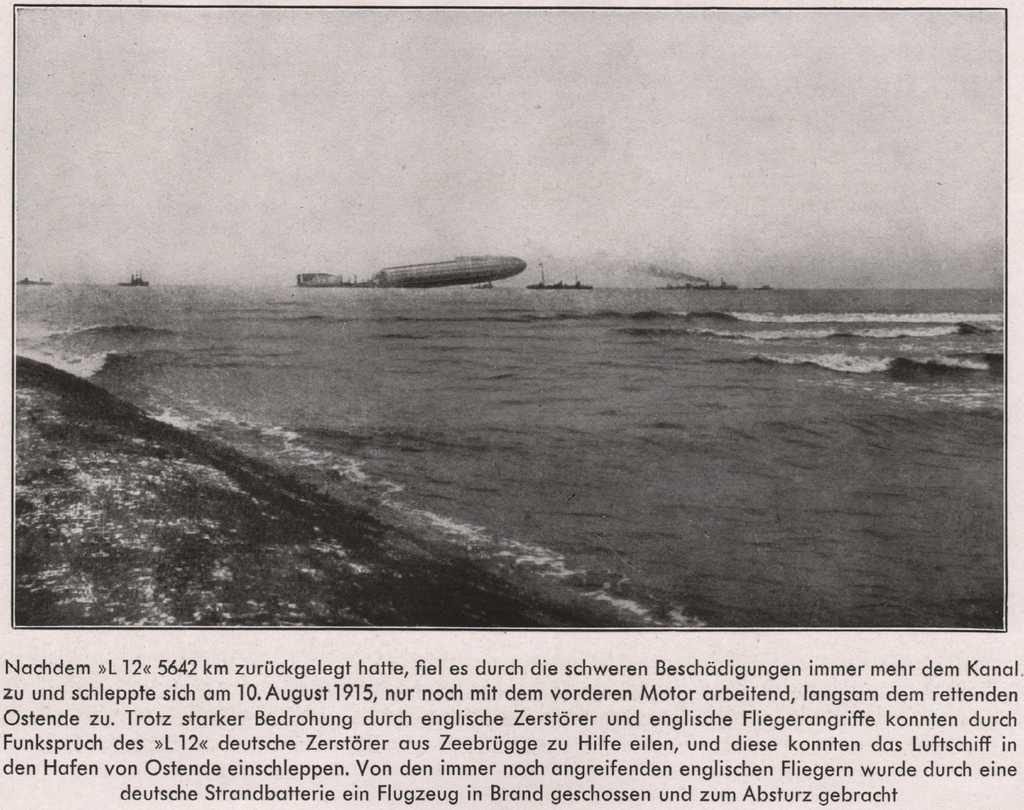What is floating on the water in the image? There are ships floating on the water in the image. What part of the natural environment is visible in the image? The sky is visible in the image. Is there any text present in the image? Yes, there is edited text at the bottom of the image. Where is the throne located in the image? There is no throne present in the image. How many horses can be seen in the image? There are no horses present in the image. 